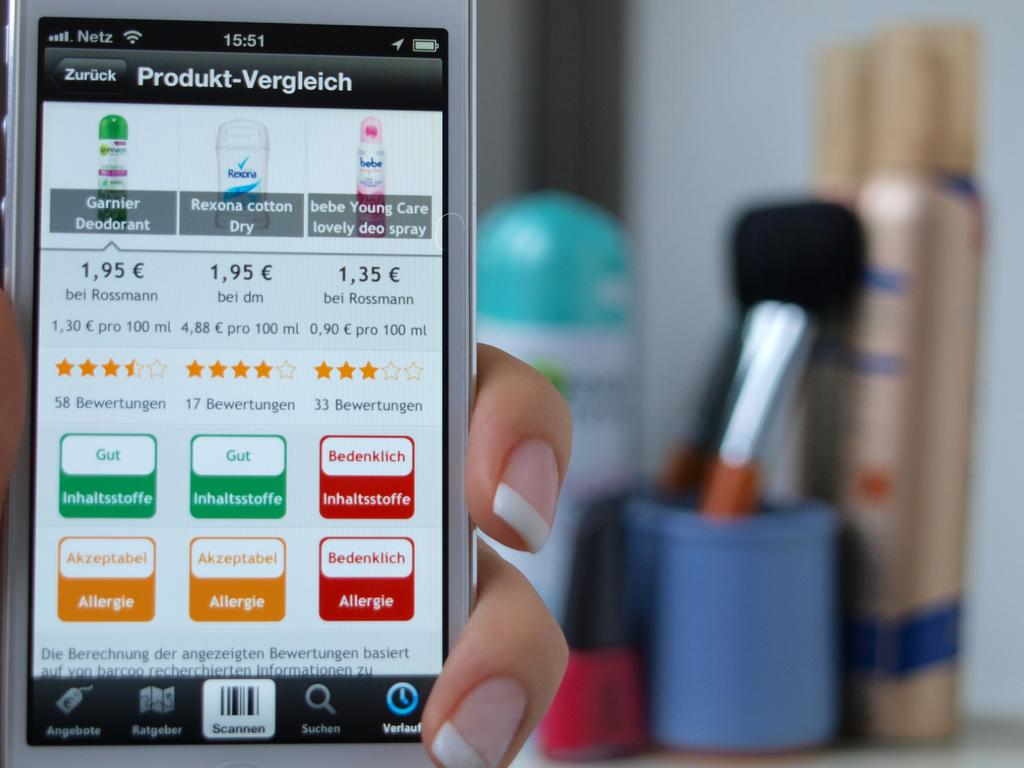<image>
Summarize the visual content of the image. A hand holding a phone with produkt-vergleich on it. 